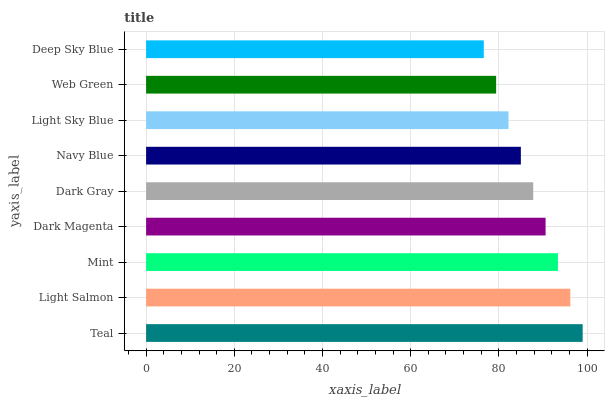Is Deep Sky Blue the minimum?
Answer yes or no. Yes. Is Teal the maximum?
Answer yes or no. Yes. Is Light Salmon the minimum?
Answer yes or no. No. Is Light Salmon the maximum?
Answer yes or no. No. Is Teal greater than Light Salmon?
Answer yes or no. Yes. Is Light Salmon less than Teal?
Answer yes or no. Yes. Is Light Salmon greater than Teal?
Answer yes or no. No. Is Teal less than Light Salmon?
Answer yes or no. No. Is Dark Gray the high median?
Answer yes or no. Yes. Is Dark Gray the low median?
Answer yes or no. Yes. Is Teal the high median?
Answer yes or no. No. Is Teal the low median?
Answer yes or no. No. 